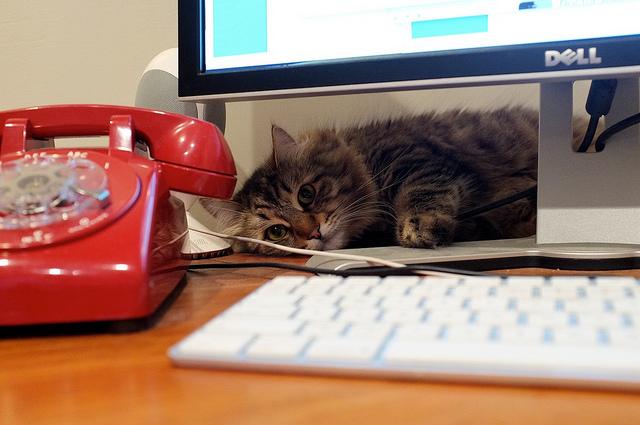Where is the keyboard in relation to the cat?
Keep it brief. Front. What brand is the monitor?
Answer briefly. Dell. What color is the phone?
Answer briefly. Red. What is the telephone style?
Quick response, please. Rotary. Is the cat about to pounce?
Short answer required. No. 